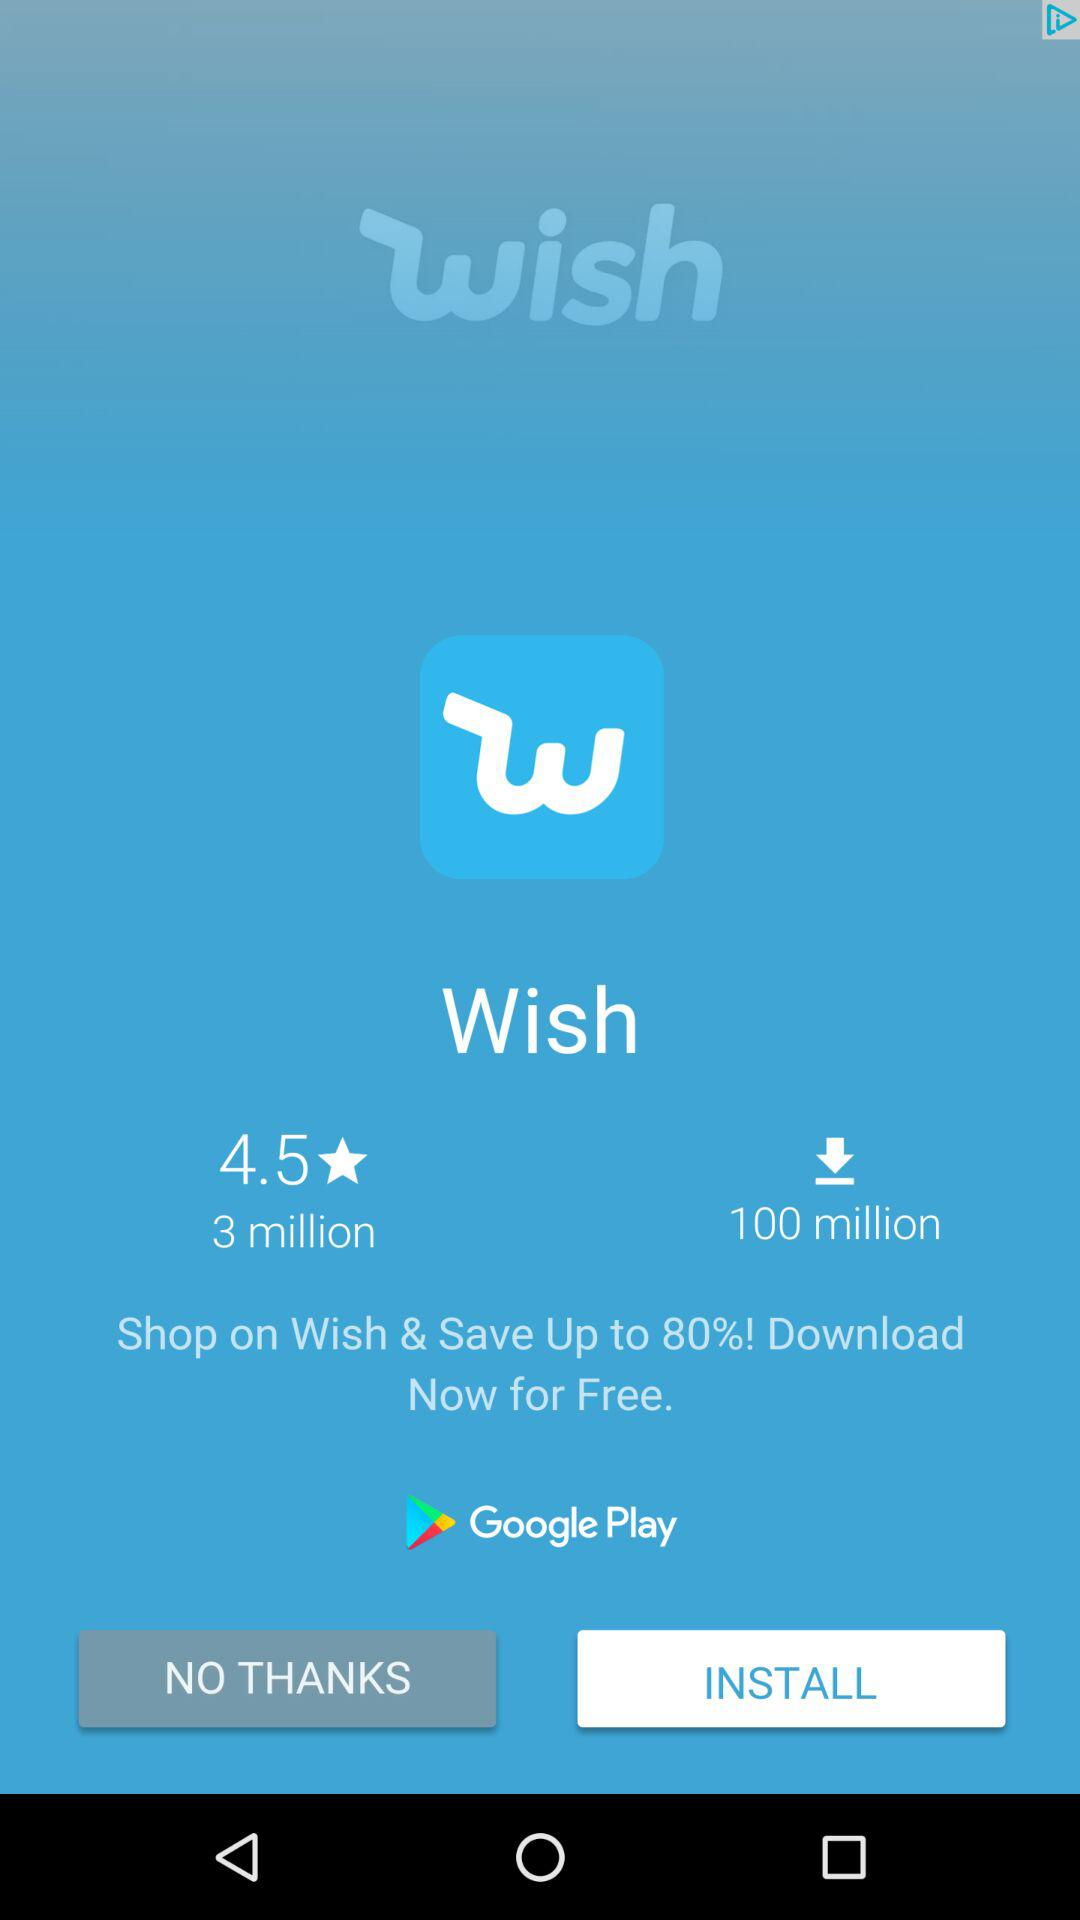How many more downloads does Wish have than reviews?
Answer the question using a single word or phrase. 97 million 